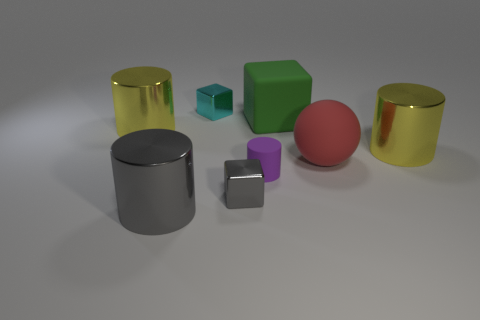Subtract all big metallic cylinders. How many cylinders are left? 1 Add 1 large yellow cylinders. How many objects exist? 9 Add 2 big cubes. How many big cubes exist? 3 Subtract all cyan cubes. How many cubes are left? 2 Subtract 0 purple cubes. How many objects are left? 8 Subtract all balls. How many objects are left? 7 Subtract 1 blocks. How many blocks are left? 2 Subtract all red cylinders. Subtract all yellow spheres. How many cylinders are left? 4 Subtract all cyan cylinders. How many gray blocks are left? 1 Subtract all shiny blocks. Subtract all small cyan objects. How many objects are left? 5 